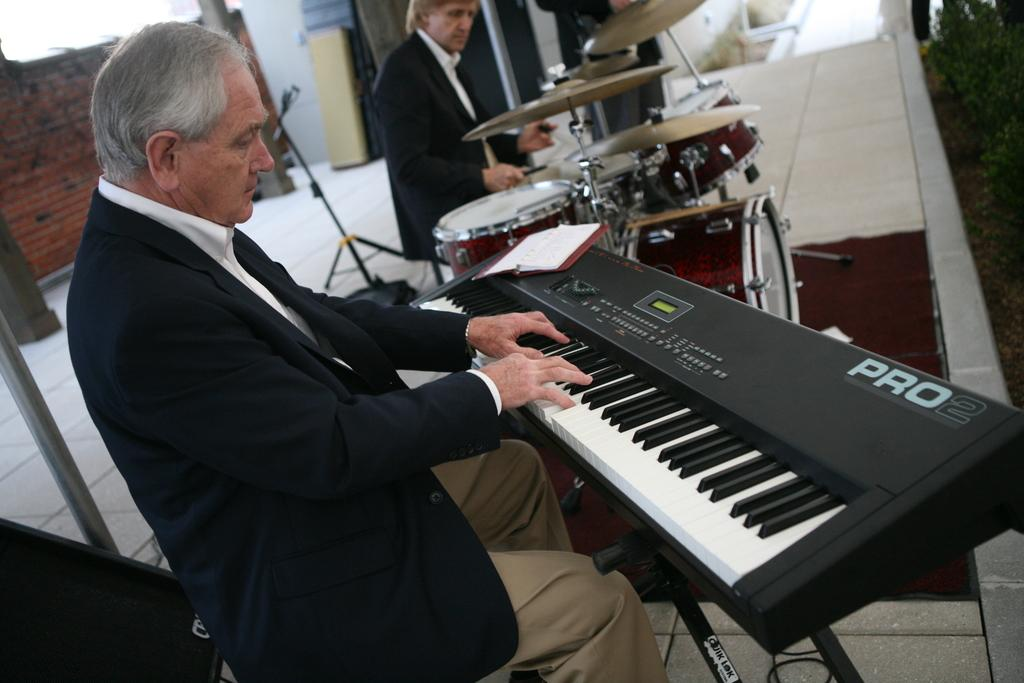What is the man in the image doing? There is a man playing piano in the image. What is the man wearing? The man is wearing a black suit. Are there any other musicians in the image? Yes, there is a man playing drums in the image. What type of surface is visible in the image? There is a floor visible in the image. What can be seen behind the musicians? There is a wall visible in the image. What type of brass instrument is the son playing in the image? There is no son or brass instrument present in the image. 